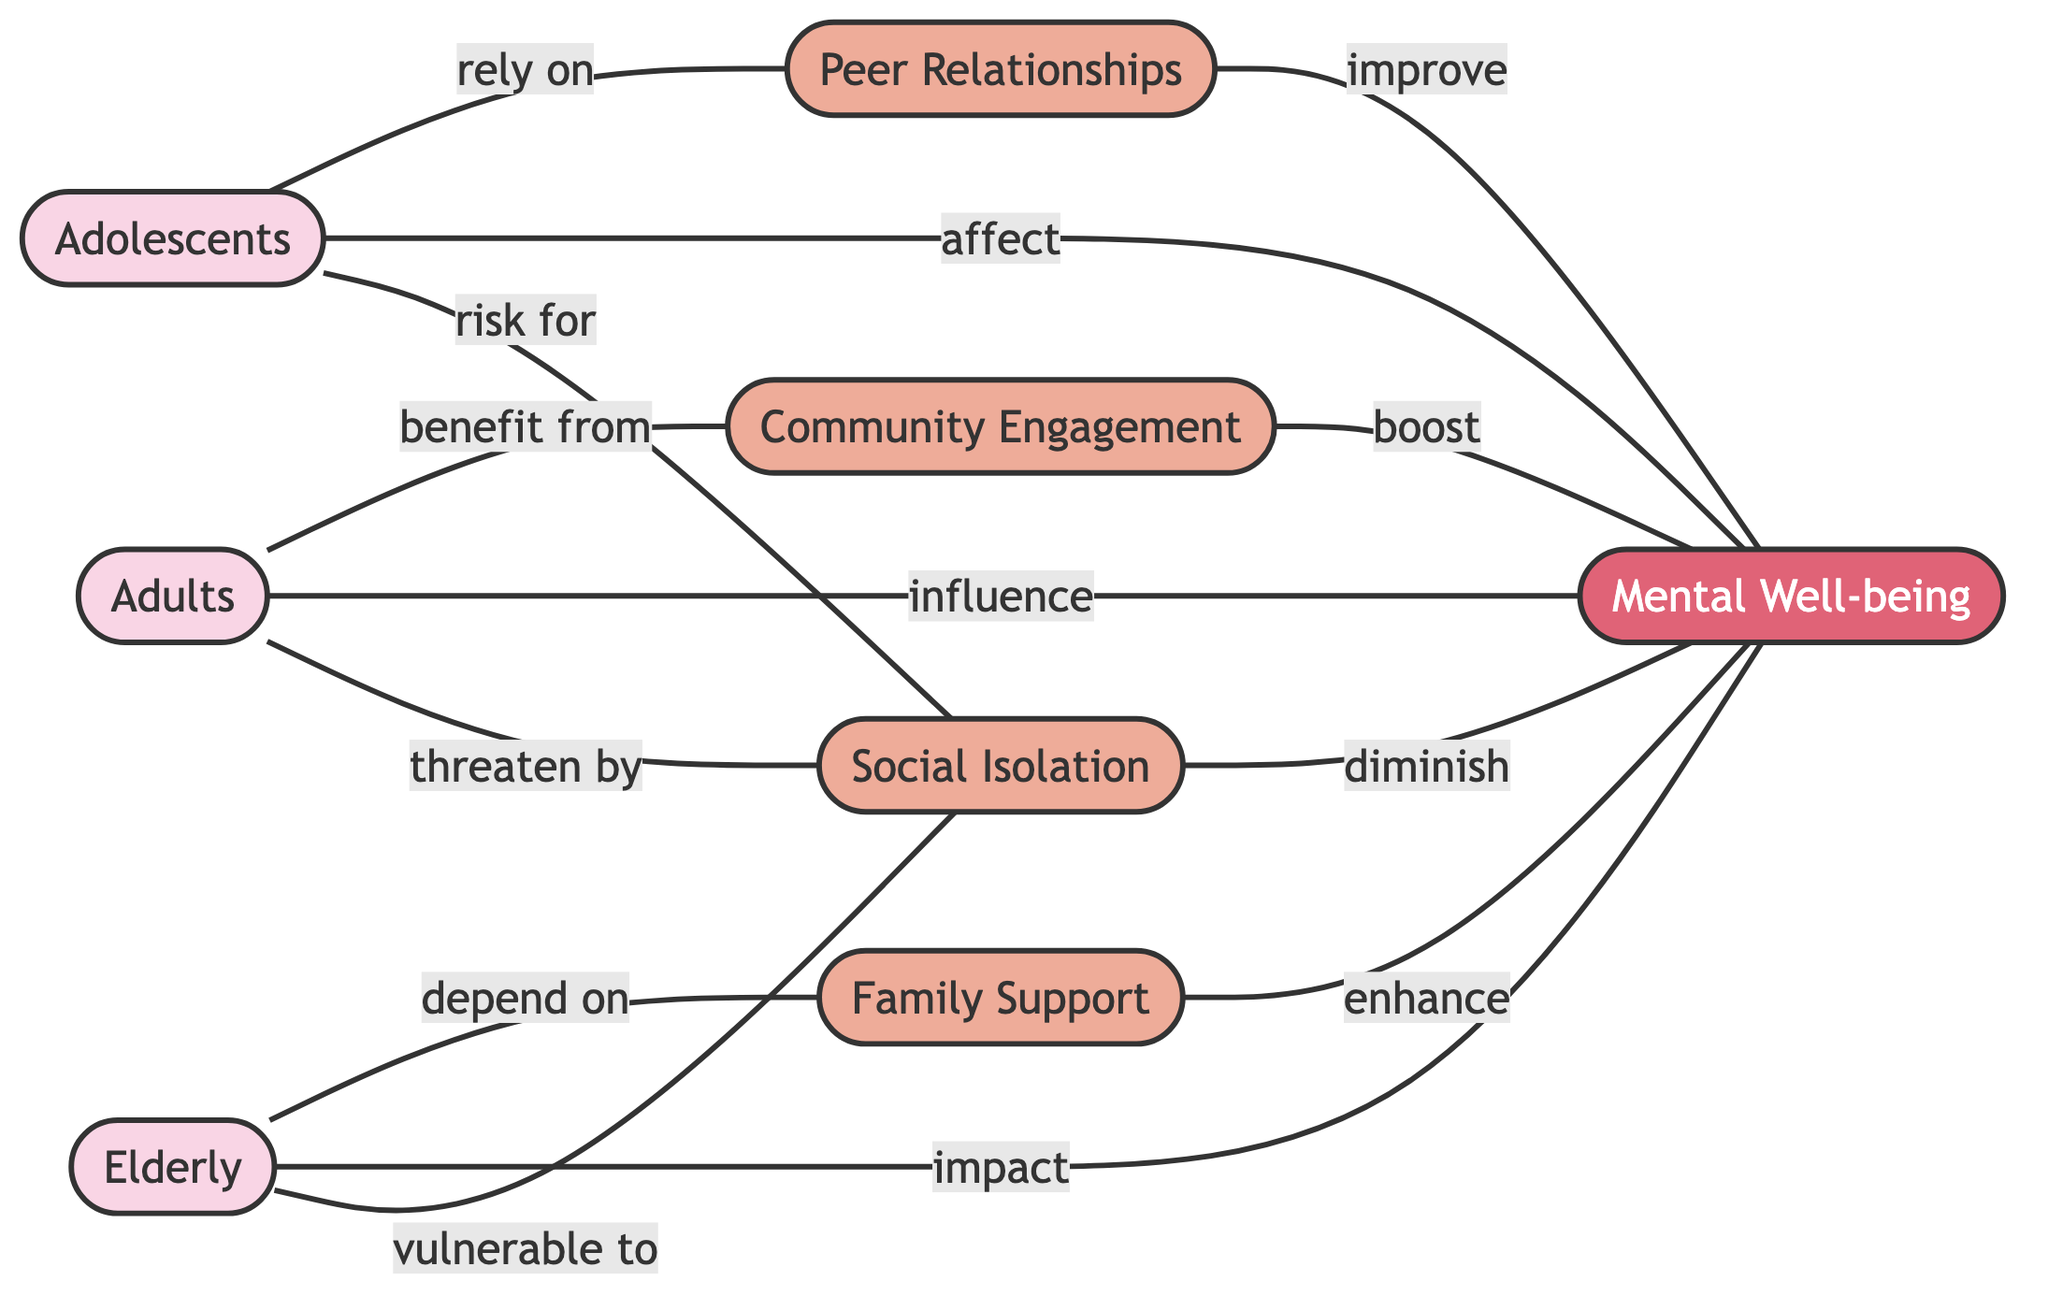What are the three age groups represented in the diagram? The diagram includes three nodes labeled "Adolescents," "Adults," and "Elderly," which represent the distinct age groups.
Answer: Adolescents, Adults, Elderly How many social factors are represented in the diagram? There are four nodes labeled "Peer Relationships," "Family Support," "Community Engagement," and "Social Isolation," indicating the number of social factors represented.
Answer: Four Which social factor do adolescents primarily rely on? The diagram indicates an edge showing that "Adolescents" rely on "Peer Relationships," which connects these two nodes directly with a labeled relationship.
Answer: Peer Relationships What is the nature of the relationship between "Community Engagement" and "Mental Well-being"? The edge connecting "Community Engagement" to "Mental Well-being" is labeled "boost," indicating that the relationship improves mental well-being.
Answer: Boost Who is specifically vulnerable to social isolation? The diagram shows that the "Elderly" node has an edge labeled "vulnerable to" connecting it to "Social Isolation," indicating that they are the group at risk.
Answer: Elderly What is the effect of "Family Support" on "Mental Well-being"? The relationship illustrated in the diagram indicates that "Family Support" has an edge labeled "enhance," suggesting it positively affects mental well-being.
Answer: Enhance Which age group is at risk for social isolation according to the diagram? The edge labeled "risk for" connects "Adolescents" to "Social Isolation," indicating that this age group faces this risk.
Answer: Adolescents How many edges are connected to "Mental Well-being"? The diagram shows a total of five edges connecting various nodes to "Mental Well-being," indicating the relationships that affect it.
Answer: Five What type of relationship does "Mental Well-being" have with "Social Isolation"? The edge connecting these two is labeled "diminish," showing that social isolation negatively impacts mental well-being.
Answer: Diminish 